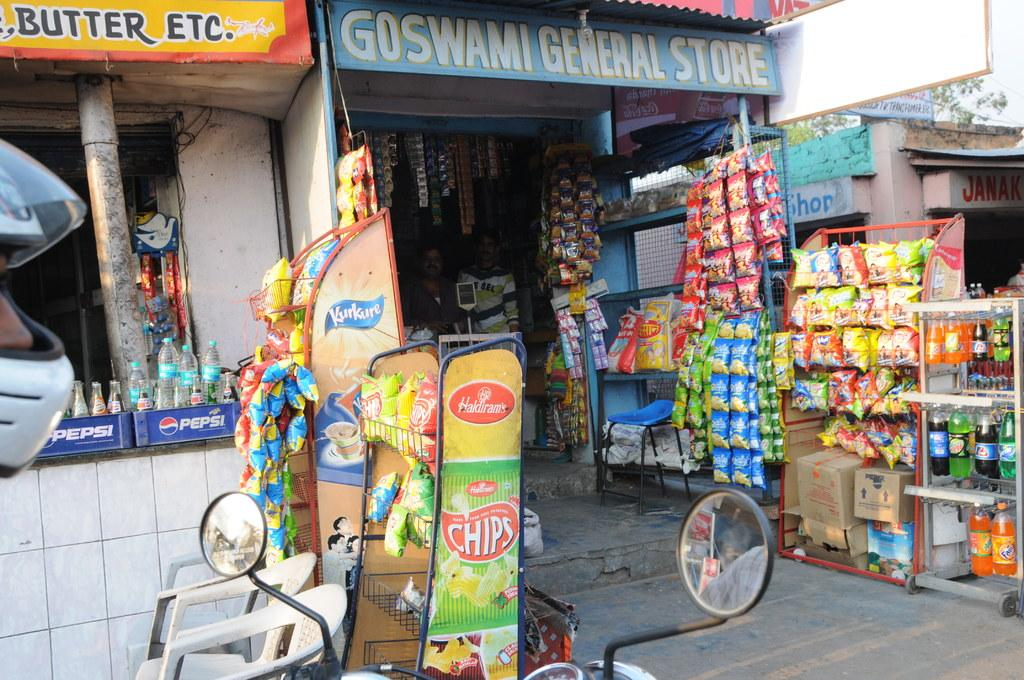<image>
Share a concise interpretation of the image provided. the store front of Goswami General Store with snack and drinks 